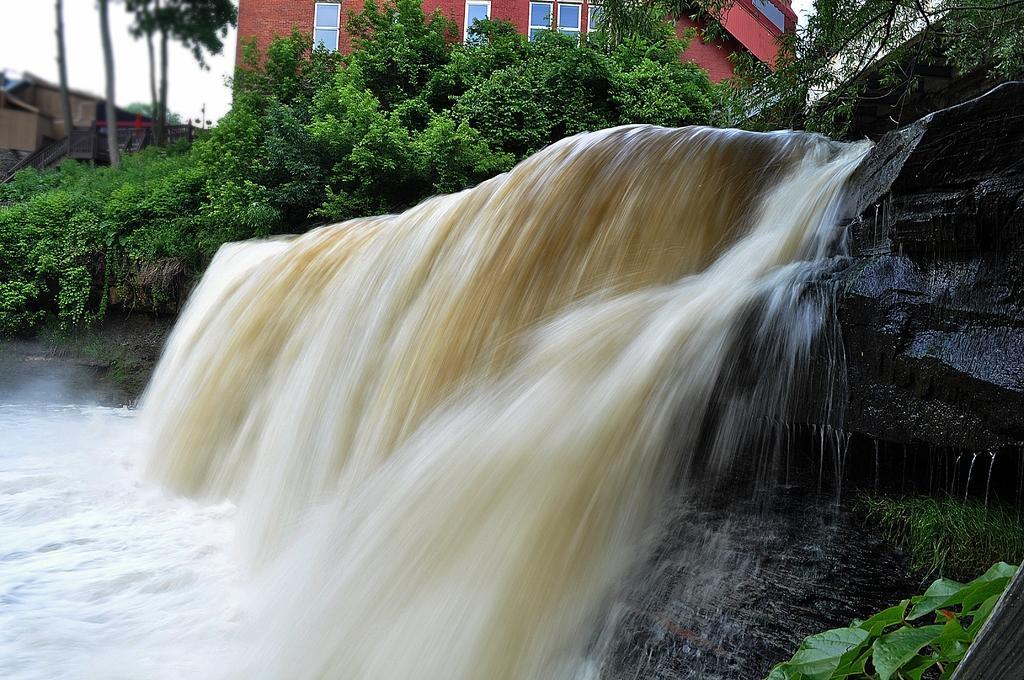How would you summarize this image in a sentence or two? In this image, we can see waterfall. On the right side of the image, we can see rocks, grass and plants. In the background, we can see trees, building, walls, glass windows, shelters, railings and sky. 